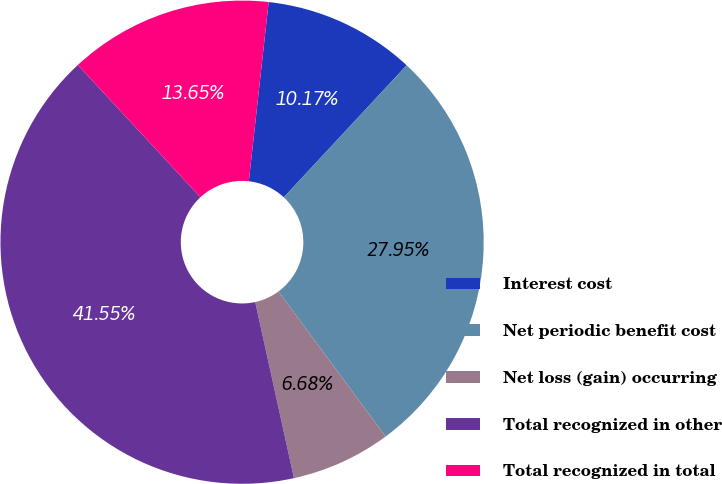Convert chart to OTSL. <chart><loc_0><loc_0><loc_500><loc_500><pie_chart><fcel>Interest cost<fcel>Net periodic benefit cost<fcel>Net loss (gain) occurring<fcel>Total recognized in other<fcel>Total recognized in total<nl><fcel>10.17%<fcel>27.95%<fcel>6.68%<fcel>41.55%<fcel>13.65%<nl></chart> 